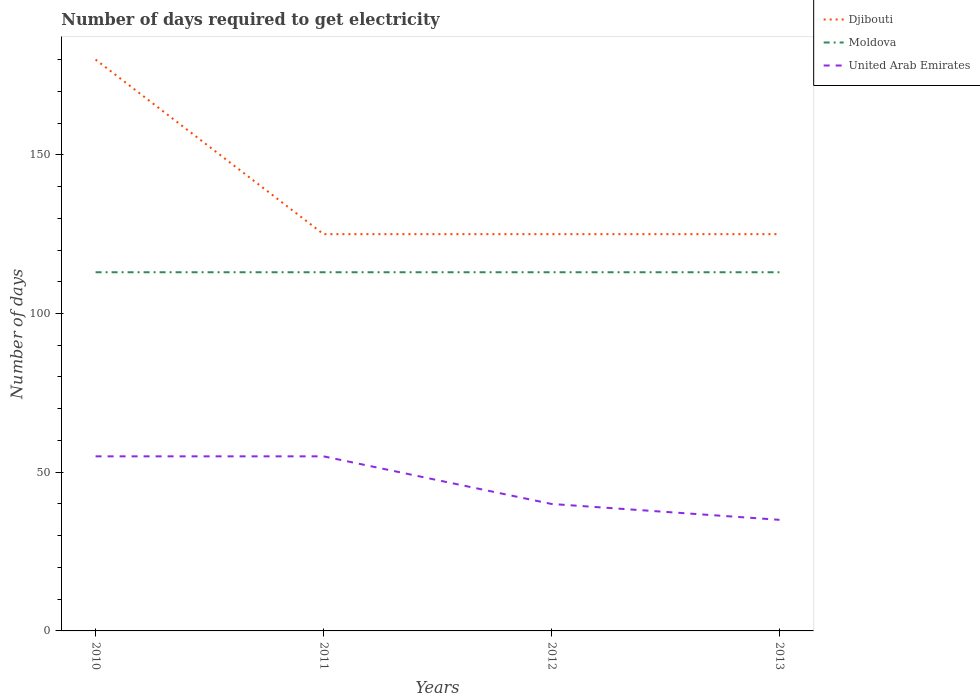Does the line corresponding to Djibouti intersect with the line corresponding to United Arab Emirates?
Your answer should be compact. No. Across all years, what is the maximum number of days required to get electricity in in Djibouti?
Keep it short and to the point. 125. In which year was the number of days required to get electricity in in Djibouti maximum?
Your response must be concise. 2011. What is the difference between the highest and the second highest number of days required to get electricity in in Djibouti?
Give a very brief answer. 55. What is the difference between the highest and the lowest number of days required to get electricity in in Moldova?
Your answer should be very brief. 0. How many lines are there?
Keep it short and to the point. 3. How many years are there in the graph?
Provide a succinct answer. 4. Are the values on the major ticks of Y-axis written in scientific E-notation?
Your response must be concise. No. Does the graph contain grids?
Offer a very short reply. No. How are the legend labels stacked?
Make the answer very short. Vertical. What is the title of the graph?
Your answer should be very brief. Number of days required to get electricity. What is the label or title of the X-axis?
Make the answer very short. Years. What is the label or title of the Y-axis?
Keep it short and to the point. Number of days. What is the Number of days in Djibouti in 2010?
Offer a terse response. 180. What is the Number of days in Moldova in 2010?
Ensure brevity in your answer.  113. What is the Number of days in Djibouti in 2011?
Make the answer very short. 125. What is the Number of days in Moldova in 2011?
Offer a terse response. 113. What is the Number of days in United Arab Emirates in 2011?
Make the answer very short. 55. What is the Number of days in Djibouti in 2012?
Make the answer very short. 125. What is the Number of days in Moldova in 2012?
Keep it short and to the point. 113. What is the Number of days in Djibouti in 2013?
Your answer should be very brief. 125. What is the Number of days in Moldova in 2013?
Your response must be concise. 113. Across all years, what is the maximum Number of days of Djibouti?
Give a very brief answer. 180. Across all years, what is the maximum Number of days in Moldova?
Ensure brevity in your answer.  113. Across all years, what is the minimum Number of days in Djibouti?
Your response must be concise. 125. Across all years, what is the minimum Number of days of Moldova?
Provide a short and direct response. 113. What is the total Number of days in Djibouti in the graph?
Give a very brief answer. 555. What is the total Number of days of Moldova in the graph?
Your answer should be compact. 452. What is the total Number of days in United Arab Emirates in the graph?
Your response must be concise. 185. What is the difference between the Number of days in Djibouti in 2010 and that in 2011?
Offer a very short reply. 55. What is the difference between the Number of days of Moldova in 2010 and that in 2012?
Keep it short and to the point. 0. What is the difference between the Number of days in Moldova in 2011 and that in 2012?
Provide a short and direct response. 0. What is the difference between the Number of days of United Arab Emirates in 2011 and that in 2012?
Your answer should be very brief. 15. What is the difference between the Number of days in Moldova in 2011 and that in 2013?
Provide a succinct answer. 0. What is the difference between the Number of days in United Arab Emirates in 2011 and that in 2013?
Offer a very short reply. 20. What is the difference between the Number of days in United Arab Emirates in 2012 and that in 2013?
Offer a very short reply. 5. What is the difference between the Number of days of Djibouti in 2010 and the Number of days of United Arab Emirates in 2011?
Provide a succinct answer. 125. What is the difference between the Number of days in Moldova in 2010 and the Number of days in United Arab Emirates in 2011?
Keep it short and to the point. 58. What is the difference between the Number of days in Djibouti in 2010 and the Number of days in United Arab Emirates in 2012?
Provide a succinct answer. 140. What is the difference between the Number of days in Moldova in 2010 and the Number of days in United Arab Emirates in 2012?
Make the answer very short. 73. What is the difference between the Number of days in Djibouti in 2010 and the Number of days in United Arab Emirates in 2013?
Keep it short and to the point. 145. What is the difference between the Number of days of Moldova in 2011 and the Number of days of United Arab Emirates in 2013?
Ensure brevity in your answer.  78. What is the difference between the Number of days of Djibouti in 2012 and the Number of days of Moldova in 2013?
Make the answer very short. 12. What is the difference between the Number of days in Djibouti in 2012 and the Number of days in United Arab Emirates in 2013?
Your answer should be compact. 90. What is the difference between the Number of days in Moldova in 2012 and the Number of days in United Arab Emirates in 2013?
Provide a succinct answer. 78. What is the average Number of days in Djibouti per year?
Give a very brief answer. 138.75. What is the average Number of days of Moldova per year?
Offer a terse response. 113. What is the average Number of days in United Arab Emirates per year?
Your response must be concise. 46.25. In the year 2010, what is the difference between the Number of days of Djibouti and Number of days of Moldova?
Provide a succinct answer. 67. In the year 2010, what is the difference between the Number of days of Djibouti and Number of days of United Arab Emirates?
Your answer should be compact. 125. In the year 2011, what is the difference between the Number of days of Djibouti and Number of days of United Arab Emirates?
Provide a succinct answer. 70. In the year 2011, what is the difference between the Number of days in Moldova and Number of days in United Arab Emirates?
Make the answer very short. 58. In the year 2012, what is the difference between the Number of days of Djibouti and Number of days of Moldova?
Offer a terse response. 12. In the year 2012, what is the difference between the Number of days in Moldova and Number of days in United Arab Emirates?
Keep it short and to the point. 73. In the year 2013, what is the difference between the Number of days in Djibouti and Number of days in Moldova?
Your response must be concise. 12. What is the ratio of the Number of days of Djibouti in 2010 to that in 2011?
Keep it short and to the point. 1.44. What is the ratio of the Number of days of Moldova in 2010 to that in 2011?
Give a very brief answer. 1. What is the ratio of the Number of days in United Arab Emirates in 2010 to that in 2011?
Provide a short and direct response. 1. What is the ratio of the Number of days in Djibouti in 2010 to that in 2012?
Ensure brevity in your answer.  1.44. What is the ratio of the Number of days in Moldova in 2010 to that in 2012?
Your answer should be compact. 1. What is the ratio of the Number of days of United Arab Emirates in 2010 to that in 2012?
Offer a terse response. 1.38. What is the ratio of the Number of days of Djibouti in 2010 to that in 2013?
Give a very brief answer. 1.44. What is the ratio of the Number of days of United Arab Emirates in 2010 to that in 2013?
Keep it short and to the point. 1.57. What is the ratio of the Number of days of Djibouti in 2011 to that in 2012?
Your answer should be compact. 1. What is the ratio of the Number of days in Moldova in 2011 to that in 2012?
Give a very brief answer. 1. What is the ratio of the Number of days in United Arab Emirates in 2011 to that in 2012?
Give a very brief answer. 1.38. What is the ratio of the Number of days in Djibouti in 2011 to that in 2013?
Give a very brief answer. 1. What is the ratio of the Number of days in United Arab Emirates in 2011 to that in 2013?
Your answer should be compact. 1.57. What is the ratio of the Number of days of Moldova in 2012 to that in 2013?
Offer a very short reply. 1. What is the difference between the highest and the second highest Number of days of Moldova?
Offer a terse response. 0. What is the difference between the highest and the lowest Number of days in Djibouti?
Your answer should be compact. 55. What is the difference between the highest and the lowest Number of days in United Arab Emirates?
Offer a very short reply. 20. 